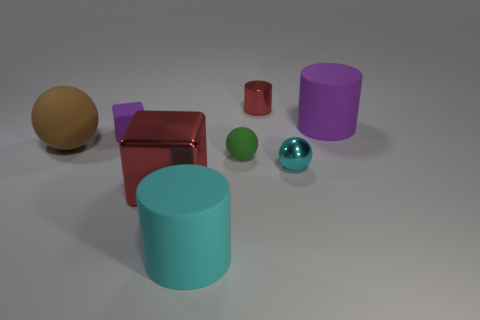Subtract all tiny cyan metal balls. How many balls are left? 2 Add 1 big rubber objects. How many objects exist? 9 Subtract all green spheres. How many spheres are left? 2 Subtract 0 gray cubes. How many objects are left? 8 Subtract all cubes. How many objects are left? 6 Subtract 1 balls. How many balls are left? 2 Subtract all gray cylinders. Subtract all purple balls. How many cylinders are left? 3 Subtract all red cylinders. How many purple blocks are left? 1 Subtract all cyan rubber cylinders. Subtract all balls. How many objects are left? 4 Add 7 big brown rubber objects. How many big brown rubber objects are left? 8 